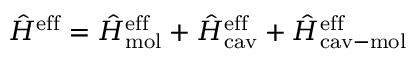<formula> <loc_0><loc_0><loc_500><loc_500>\hat { H } ^ { e f f } = \hat { H } _ { m o l } ^ { e f f } + \hat { H } _ { c a v } ^ { e f f } + \hat { H } _ { c a v - m o l } ^ { e f f }</formula> 